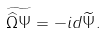Convert formula to latex. <formula><loc_0><loc_0><loc_500><loc_500>\widetilde { \widehat { \Omega } \Psi } = - i d \widetilde { \Psi } .</formula> 